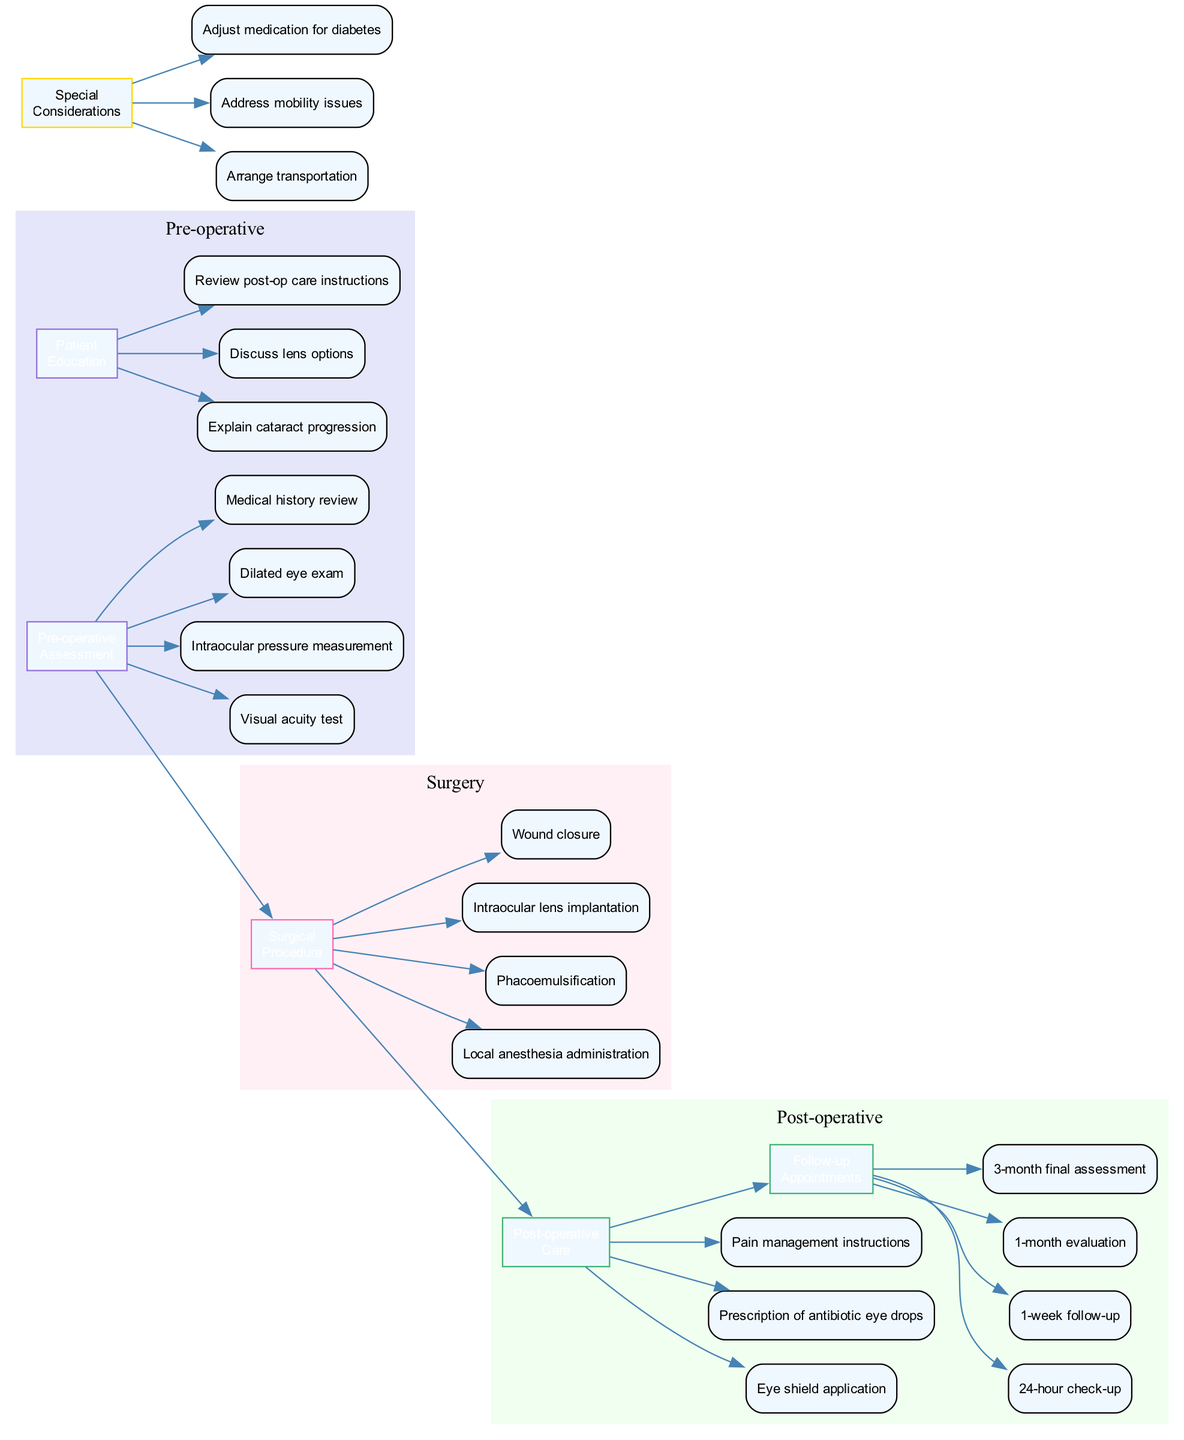What are the elements included in the pre-operative assessment? The diagram lists four specific assessments, which are "Visual acuity test," "Intraocular pressure measurement," "Dilated eye exam," and "Medical history review." These items are found connected to the "Pre-operative Assessment" node.
Answer: Visual acuity test, Intraocular pressure measurement, Dilated eye exam, Medical history review How many follow-up appointments are listed? The diagram indicates four distinct follow-up appointments: "24-hour check-up," "1-week follow-up," "1-month evaluation," and "3-month final assessment." All these appointments branch from the "Follow-up Appointments" node.
Answer: 4 What is the next step after the surgical procedure? According to the flow of the diagram, the next step after the "Surgical Procedure" is "Post-operative Care." This connection is indicated by the edge linking these two nodes.
Answer: Post-operative Care What is the purpose of patient education? The diagram specifies three main topics under "Patient Education": "Explain cataract progression," "Discuss lens options," and "Review post-op care instructions." These items indicate the focus of patient education, which is about preparing the patient for surgery and care afterward.
Answer: Prepare for surgery and care afterward What special consideration is mentioned regarding diabetes? The diagram explicitly lists "Adjust medication for diabetes" under the "Special Considerations." This points to the importance of managing diabetes as part of the patient's pre-operative and post-operative care cycle.
Answer: Adjust medication for diabetes What is the relationship between "Post-operative Care" and "Follow-up Appointments"? The diagram shows an arrow or edge connecting "Post-operative Care" directly to "Follow-up Appointments," signifying that follow-ups occur after the post-operative phase. This indicates a sequential relationship in the clinical pathway.
Answer: Sequential relationship 